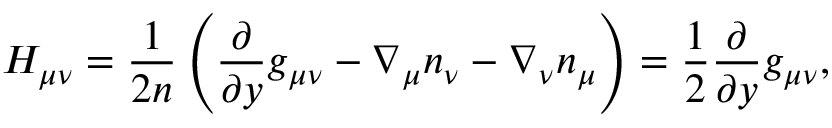Convert formula to latex. <formula><loc_0><loc_0><loc_500><loc_500>H _ { \mu \nu } = \frac { 1 } 2 n } \left ( \frac { \partial } { \partial y } g _ { \mu \nu } - \nabla _ { \mu } n _ { \nu } - \nabla _ { \nu } n _ { \mu } \right ) = \frac { 1 } { 2 } \frac { \partial } { \partial y } g _ { \mu \nu } ,</formula> 